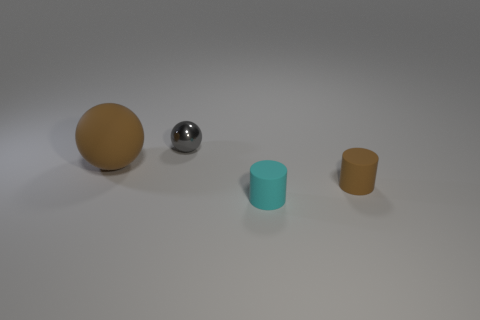There is another object that is the same color as the large rubber thing; what shape is it?
Ensure brevity in your answer.  Cylinder. Is the number of small spheres left of the shiny ball the same as the number of small matte cylinders?
Ensure brevity in your answer.  No. There is a tiny thing that is the same shape as the big thing; what is its color?
Offer a terse response. Gray. Is the material of the brown object that is on the right side of the cyan matte thing the same as the large ball?
Your response must be concise. Yes. How many small objects are either matte cylinders or cyan things?
Your answer should be compact. 2. The gray sphere has what size?
Keep it short and to the point. Small. There is a brown matte cylinder; does it have the same size as the brown object that is to the left of the small cyan matte cylinder?
Keep it short and to the point. No. How many green objects are either large things or small rubber objects?
Your answer should be compact. 0. How many tiny purple metal spheres are there?
Your answer should be very brief. 0. What is the size of the ball on the left side of the tiny shiny thing?
Offer a very short reply. Large. 